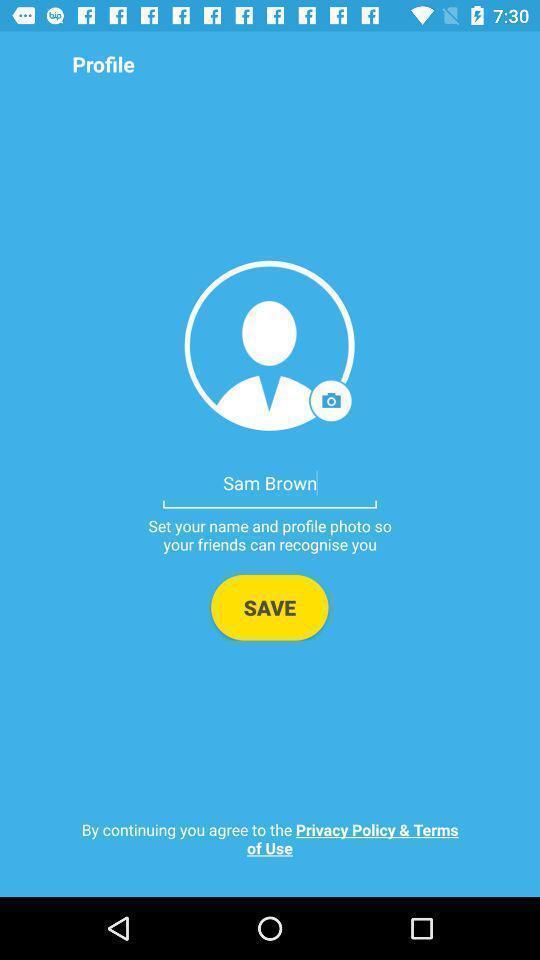Tell me about the visual elements in this screen capture. Sign in page of an social app. 